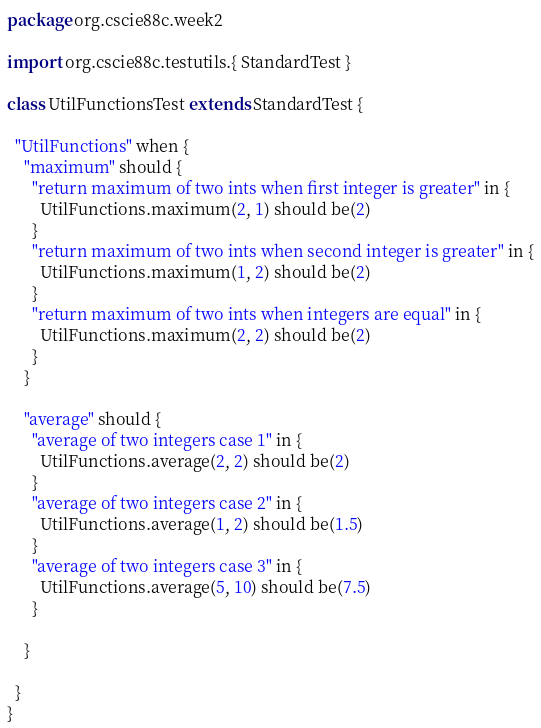Convert code to text. <code><loc_0><loc_0><loc_500><loc_500><_Scala_>package org.cscie88c.week2

import org.cscie88c.testutils.{ StandardTest }

class UtilFunctionsTest extends StandardTest {

  "UtilFunctions" when {
    "maximum" should {
      "return maximum of two ints when first integer is greater" in {
        UtilFunctions.maximum(2, 1) should be(2)
      }
      "return maximum of two ints when second integer is greater" in {
        UtilFunctions.maximum(1, 2) should be(2)
      }
      "return maximum of two ints when integers are equal" in {
        UtilFunctions.maximum(2, 2) should be(2)
      }
    }

    "average" should {
      "average of two integers case 1" in {
        UtilFunctions.average(2, 2) should be(2)
      }
      "average of two integers case 2" in {
        UtilFunctions.average(1, 2) should be(1.5)
      }
      "average of two integers case 3" in {
        UtilFunctions.average(5, 10) should be(7.5)
      }

    }

  }
}
</code> 